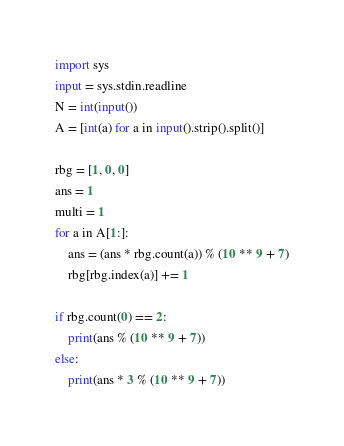Convert code to text. <code><loc_0><loc_0><loc_500><loc_500><_Python_>import sys
input = sys.stdin.readline
N = int(input())
A = [int(a) for a in input().strip().split()]

rbg = [1, 0, 0]
ans = 1
multi = 1
for a in A[1:]:
    ans = (ans * rbg.count(a)) % (10 ** 9 + 7)
    rbg[rbg.index(a)] += 1

if rbg.count(0) == 2:
    print(ans % (10 ** 9 + 7))
else:
    print(ans * 3 % (10 ** 9 + 7))</code> 